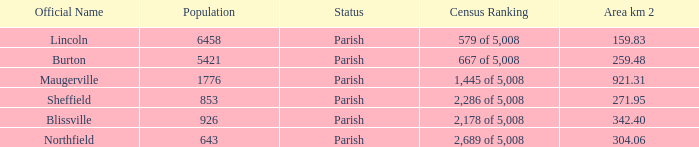What are the official name(s) of places with an area of 304.06 km2? Northfield. 